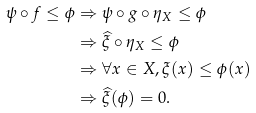Convert formula to latex. <formula><loc_0><loc_0><loc_500><loc_500>\psi \circ f \leq \phi & \Rightarrow \psi \circ g \circ \eta _ { X } \leq \phi \\ & \Rightarrow \widehat { \xi } \circ \eta _ { X } \leq \phi \\ & \Rightarrow \forall x \in X , \xi ( x ) \leq \phi ( x ) \\ & \Rightarrow \widehat { \xi } ( \phi ) = 0 .</formula> 